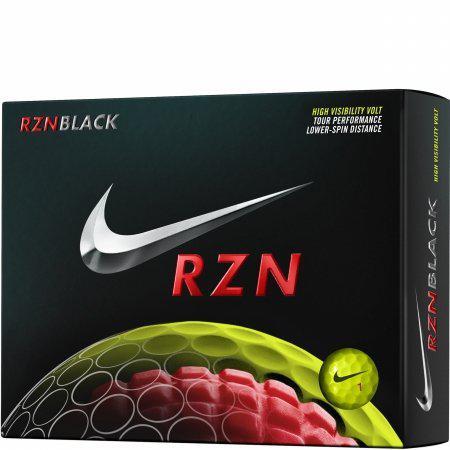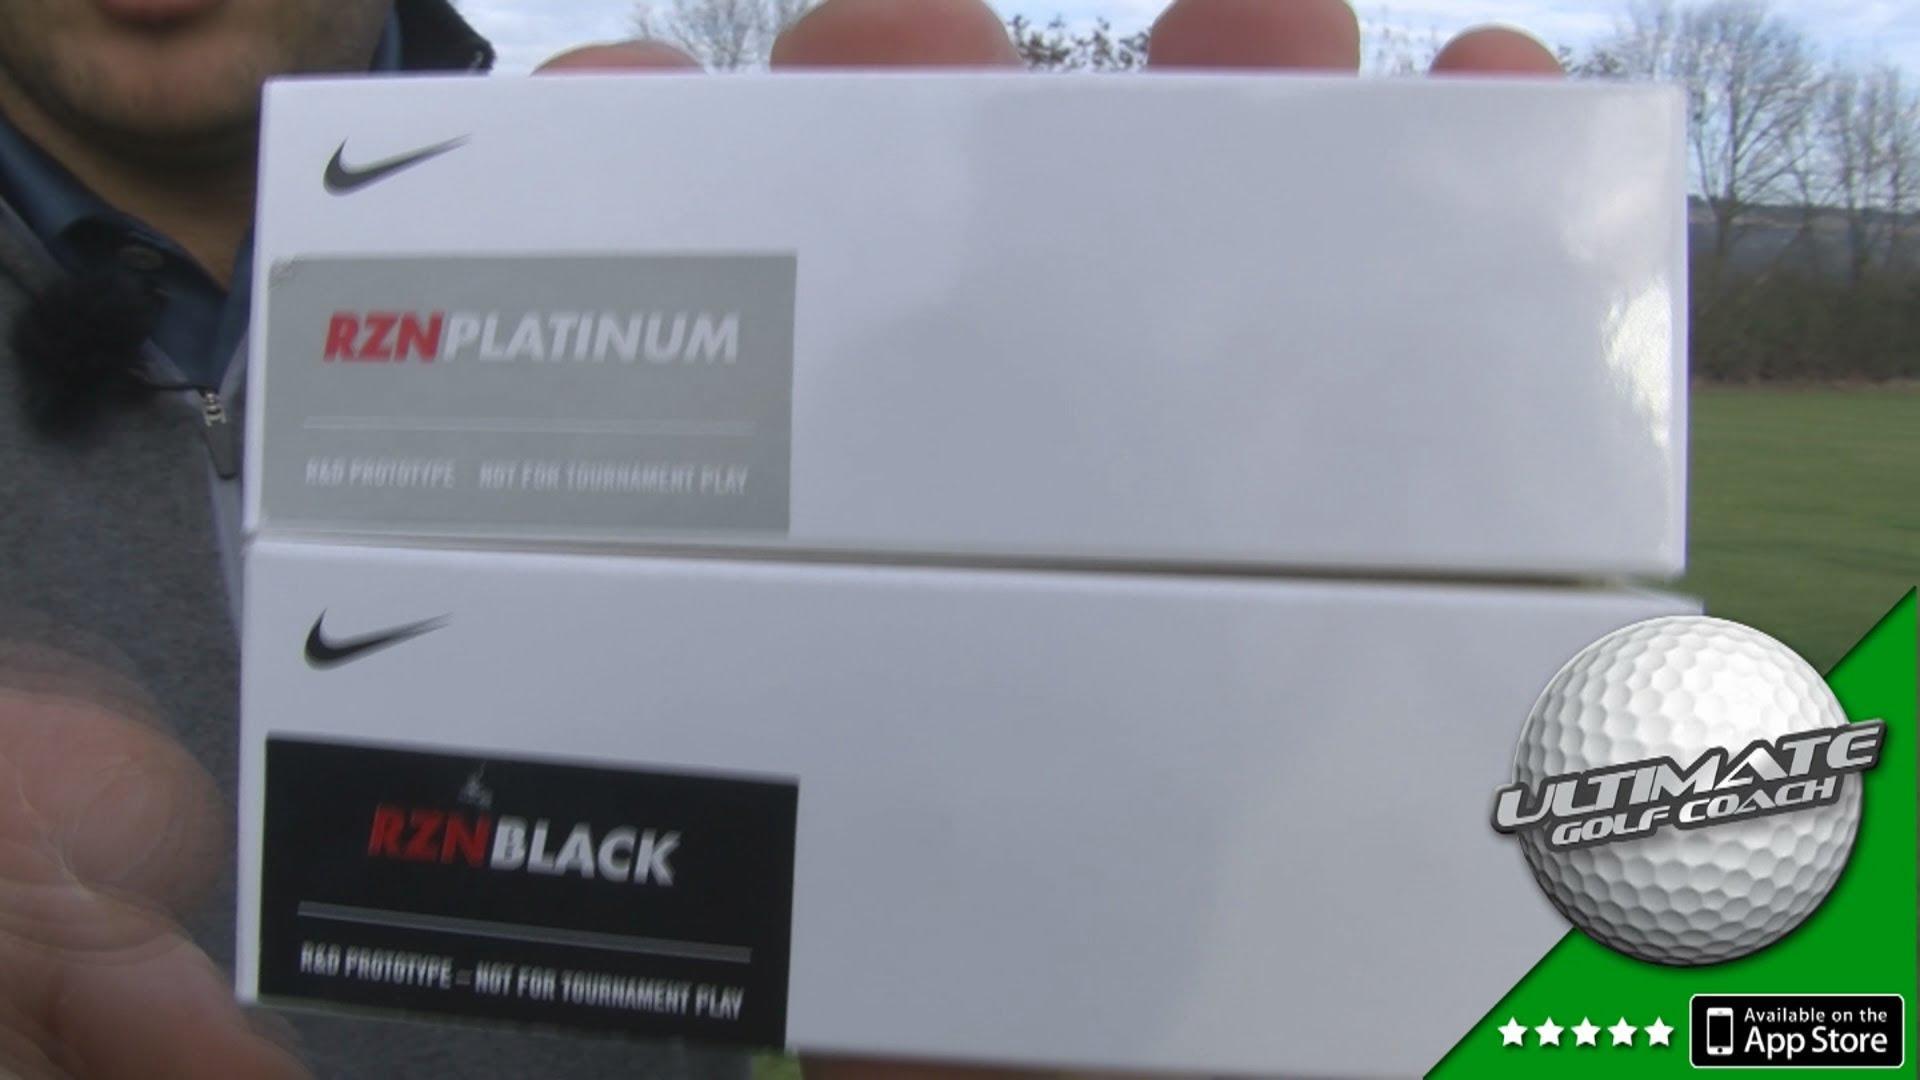The first image is the image on the left, the second image is the image on the right. Analyze the images presented: Is the assertion "There are exactly three golf balls that aren't in a box." valid? Answer yes or no. No. The first image is the image on the left, the second image is the image on the right. For the images displayed, is the sentence "In at least one image there are two black boxes that have silver and red on them." factually correct? Answer yes or no. No. 